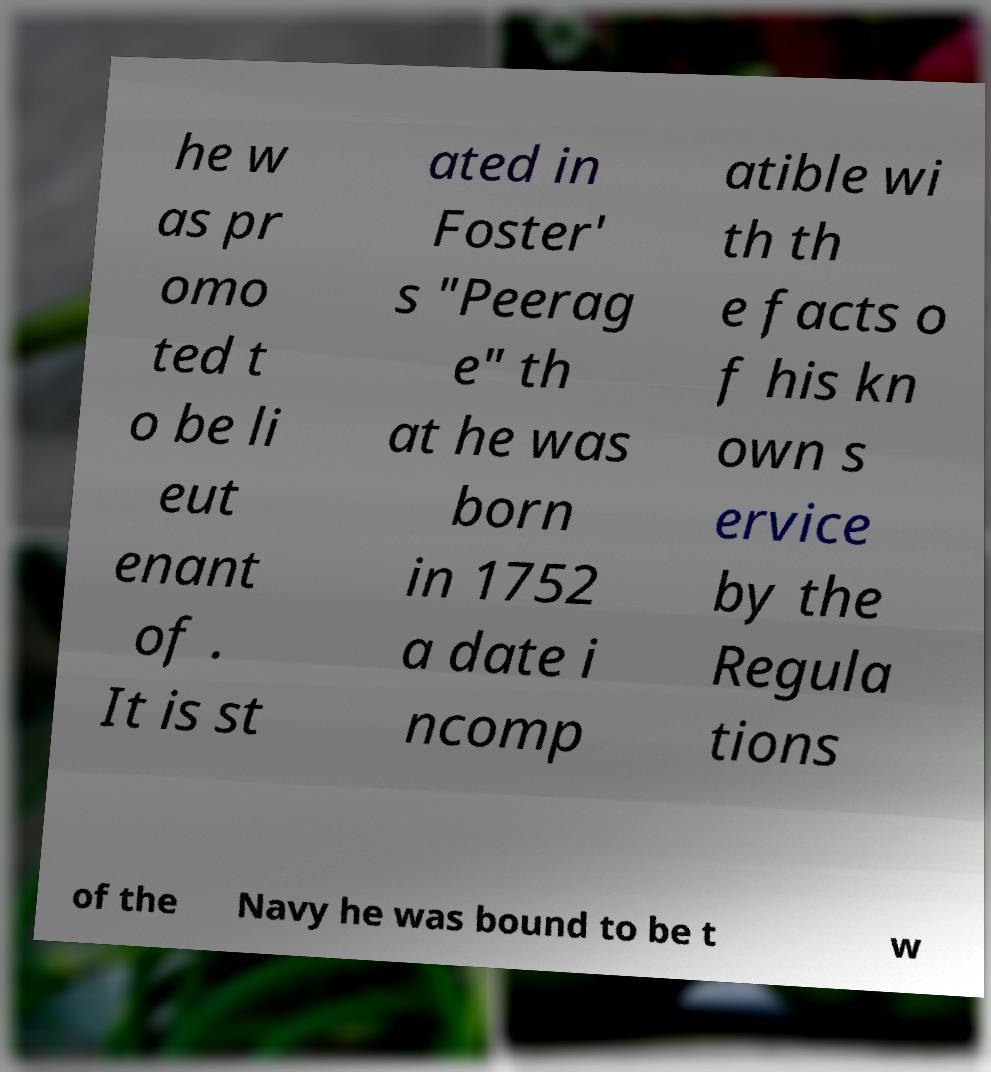Can you accurately transcribe the text from the provided image for me? he w as pr omo ted t o be li eut enant of . It is st ated in Foster' s "Peerag e" th at he was born in 1752 a date i ncomp atible wi th th e facts o f his kn own s ervice by the Regula tions of the Navy he was bound to be t w 